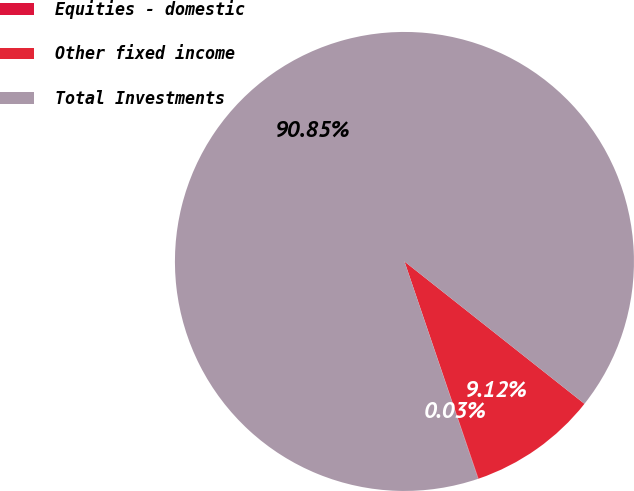<chart> <loc_0><loc_0><loc_500><loc_500><pie_chart><fcel>Equities - domestic<fcel>Other fixed income<fcel>Total Investments<nl><fcel>0.03%<fcel>9.12%<fcel>90.85%<nl></chart> 